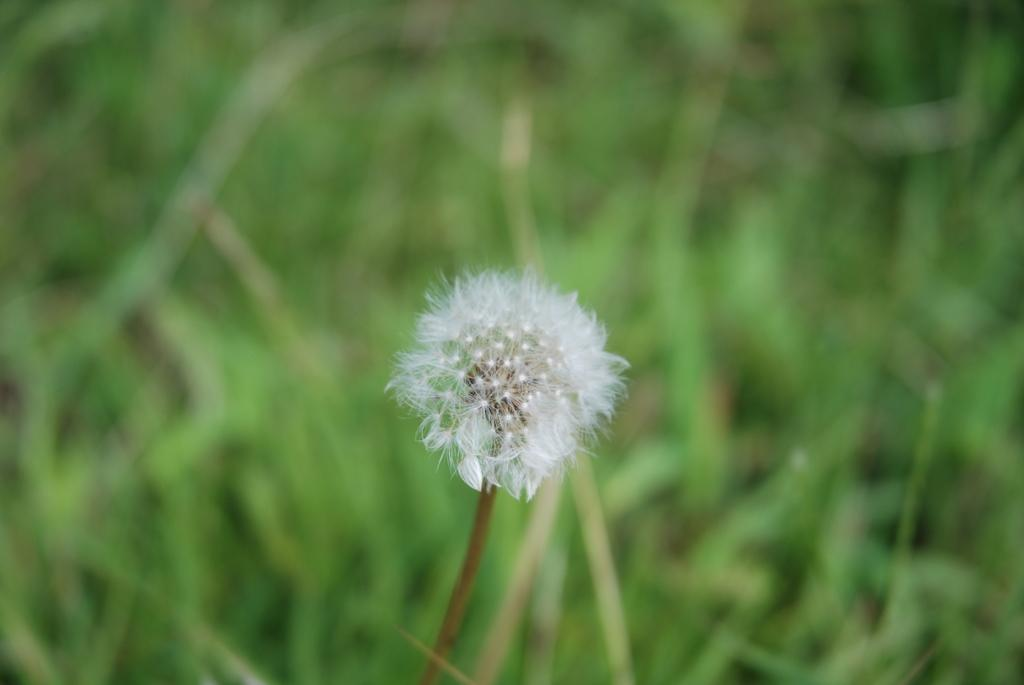What is the main subject of the image? There is a flower in the image. What else can be seen in the background of the image? There are leaves visible in the background of the image. How would you describe the clarity of the image? The image is blurry. Can you see a parcel being delivered on the seashore in the image? There is no parcel or seashore present in the image; it features a flower and leaves. What is the tongue of the flower doing in the image? There is no tongue present in the image, as flowers do not have tongues. 